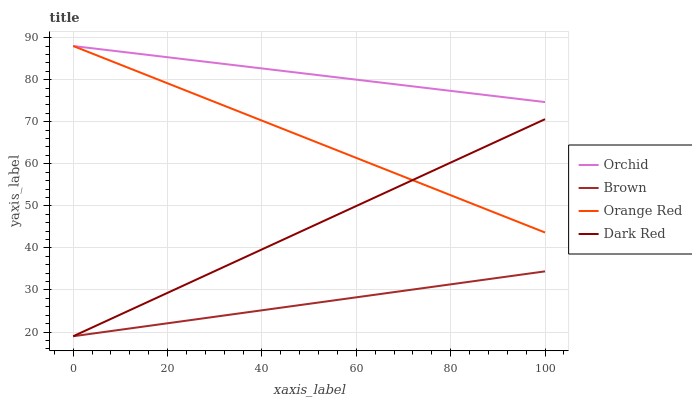Does Brown have the minimum area under the curve?
Answer yes or no. Yes. Does Orchid have the maximum area under the curve?
Answer yes or no. Yes. Does Dark Red have the minimum area under the curve?
Answer yes or no. No. Does Dark Red have the maximum area under the curve?
Answer yes or no. No. Is Brown the smoothest?
Answer yes or no. Yes. Is Orange Red the roughest?
Answer yes or no. Yes. Is Dark Red the smoothest?
Answer yes or no. No. Is Dark Red the roughest?
Answer yes or no. No. Does Orange Red have the lowest value?
Answer yes or no. No. Does Orchid have the highest value?
Answer yes or no. Yes. Does Dark Red have the highest value?
Answer yes or no. No. Is Dark Red less than Orchid?
Answer yes or no. Yes. Is Orchid greater than Dark Red?
Answer yes or no. Yes. Does Dark Red intersect Orange Red?
Answer yes or no. Yes. Is Dark Red less than Orange Red?
Answer yes or no. No. Is Dark Red greater than Orange Red?
Answer yes or no. No. Does Dark Red intersect Orchid?
Answer yes or no. No. 